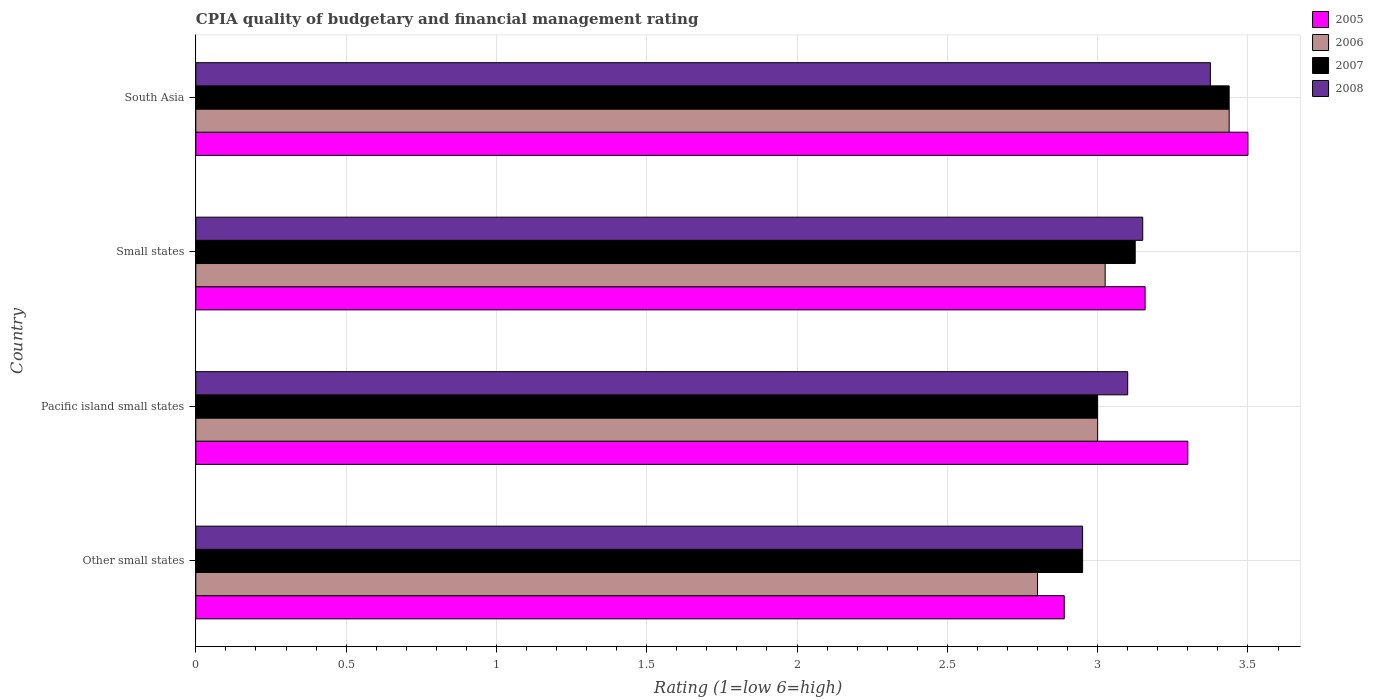Are the number of bars per tick equal to the number of legend labels?
Make the answer very short. Yes. How many bars are there on the 4th tick from the top?
Offer a terse response. 4. How many bars are there on the 2nd tick from the bottom?
Your response must be concise. 4. What is the label of the 1st group of bars from the top?
Offer a very short reply. South Asia. What is the CPIA rating in 2008 in Pacific island small states?
Offer a terse response. 3.1. Across all countries, what is the maximum CPIA rating in 2006?
Provide a short and direct response. 3.44. Across all countries, what is the minimum CPIA rating in 2007?
Your response must be concise. 2.95. In which country was the CPIA rating in 2006 minimum?
Provide a short and direct response. Other small states. What is the total CPIA rating in 2005 in the graph?
Give a very brief answer. 12.85. What is the difference between the CPIA rating in 2006 in Other small states and that in Small states?
Your response must be concise. -0.23. What is the difference between the CPIA rating in 2006 in Other small states and the CPIA rating in 2005 in Small states?
Provide a short and direct response. -0.36. What is the average CPIA rating in 2008 per country?
Offer a very short reply. 3.14. What is the difference between the CPIA rating in 2006 and CPIA rating in 2008 in Small states?
Make the answer very short. -0.12. In how many countries, is the CPIA rating in 2008 greater than 2.1 ?
Make the answer very short. 4. What is the ratio of the CPIA rating in 2007 in Other small states to that in Small states?
Ensure brevity in your answer.  0.94. Is the CPIA rating in 2006 in Other small states less than that in South Asia?
Your answer should be very brief. Yes. What is the difference between the highest and the second highest CPIA rating in 2006?
Give a very brief answer. 0.41. What is the difference between the highest and the lowest CPIA rating in 2008?
Make the answer very short. 0.42. In how many countries, is the CPIA rating in 2008 greater than the average CPIA rating in 2008 taken over all countries?
Keep it short and to the point. 2. What does the 1st bar from the top in Pacific island small states represents?
Provide a succinct answer. 2008. Are all the bars in the graph horizontal?
Provide a succinct answer. Yes. How many countries are there in the graph?
Ensure brevity in your answer.  4. Are the values on the major ticks of X-axis written in scientific E-notation?
Provide a succinct answer. No. Does the graph contain grids?
Offer a very short reply. Yes. Where does the legend appear in the graph?
Provide a succinct answer. Top right. How many legend labels are there?
Your answer should be very brief. 4. What is the title of the graph?
Your response must be concise. CPIA quality of budgetary and financial management rating. What is the label or title of the X-axis?
Offer a terse response. Rating (1=low 6=high). What is the Rating (1=low 6=high) in 2005 in Other small states?
Offer a terse response. 2.89. What is the Rating (1=low 6=high) in 2006 in Other small states?
Provide a succinct answer. 2.8. What is the Rating (1=low 6=high) in 2007 in Other small states?
Your response must be concise. 2.95. What is the Rating (1=low 6=high) in 2008 in Other small states?
Your answer should be compact. 2.95. What is the Rating (1=low 6=high) in 2005 in Pacific island small states?
Offer a terse response. 3.3. What is the Rating (1=low 6=high) in 2008 in Pacific island small states?
Make the answer very short. 3.1. What is the Rating (1=low 6=high) in 2005 in Small states?
Provide a short and direct response. 3.16. What is the Rating (1=low 6=high) of 2006 in Small states?
Keep it short and to the point. 3.02. What is the Rating (1=low 6=high) in 2007 in Small states?
Your answer should be very brief. 3.12. What is the Rating (1=low 6=high) of 2008 in Small states?
Make the answer very short. 3.15. What is the Rating (1=low 6=high) in 2005 in South Asia?
Keep it short and to the point. 3.5. What is the Rating (1=low 6=high) of 2006 in South Asia?
Provide a succinct answer. 3.44. What is the Rating (1=low 6=high) of 2007 in South Asia?
Provide a short and direct response. 3.44. What is the Rating (1=low 6=high) in 2008 in South Asia?
Offer a very short reply. 3.38. Across all countries, what is the maximum Rating (1=low 6=high) of 2006?
Make the answer very short. 3.44. Across all countries, what is the maximum Rating (1=low 6=high) of 2007?
Keep it short and to the point. 3.44. Across all countries, what is the maximum Rating (1=low 6=high) of 2008?
Offer a terse response. 3.38. Across all countries, what is the minimum Rating (1=low 6=high) in 2005?
Offer a terse response. 2.89. Across all countries, what is the minimum Rating (1=low 6=high) in 2007?
Your answer should be very brief. 2.95. Across all countries, what is the minimum Rating (1=low 6=high) of 2008?
Provide a short and direct response. 2.95. What is the total Rating (1=low 6=high) in 2005 in the graph?
Provide a succinct answer. 12.85. What is the total Rating (1=low 6=high) in 2006 in the graph?
Offer a terse response. 12.26. What is the total Rating (1=low 6=high) in 2007 in the graph?
Your answer should be very brief. 12.51. What is the total Rating (1=low 6=high) in 2008 in the graph?
Offer a very short reply. 12.57. What is the difference between the Rating (1=low 6=high) of 2005 in Other small states and that in Pacific island small states?
Ensure brevity in your answer.  -0.41. What is the difference between the Rating (1=low 6=high) of 2005 in Other small states and that in Small states?
Your response must be concise. -0.27. What is the difference between the Rating (1=low 6=high) in 2006 in Other small states and that in Small states?
Offer a very short reply. -0.23. What is the difference between the Rating (1=low 6=high) of 2007 in Other small states and that in Small states?
Provide a succinct answer. -0.17. What is the difference between the Rating (1=low 6=high) in 2005 in Other small states and that in South Asia?
Provide a short and direct response. -0.61. What is the difference between the Rating (1=low 6=high) in 2006 in Other small states and that in South Asia?
Make the answer very short. -0.64. What is the difference between the Rating (1=low 6=high) of 2007 in Other small states and that in South Asia?
Offer a very short reply. -0.49. What is the difference between the Rating (1=low 6=high) of 2008 in Other small states and that in South Asia?
Your response must be concise. -0.42. What is the difference between the Rating (1=low 6=high) in 2005 in Pacific island small states and that in Small states?
Make the answer very short. 0.14. What is the difference between the Rating (1=low 6=high) in 2006 in Pacific island small states and that in Small states?
Provide a succinct answer. -0.03. What is the difference between the Rating (1=low 6=high) of 2007 in Pacific island small states and that in Small states?
Keep it short and to the point. -0.12. What is the difference between the Rating (1=low 6=high) in 2008 in Pacific island small states and that in Small states?
Offer a terse response. -0.05. What is the difference between the Rating (1=low 6=high) in 2006 in Pacific island small states and that in South Asia?
Offer a terse response. -0.44. What is the difference between the Rating (1=low 6=high) in 2007 in Pacific island small states and that in South Asia?
Make the answer very short. -0.44. What is the difference between the Rating (1=low 6=high) in 2008 in Pacific island small states and that in South Asia?
Offer a very short reply. -0.28. What is the difference between the Rating (1=low 6=high) of 2005 in Small states and that in South Asia?
Ensure brevity in your answer.  -0.34. What is the difference between the Rating (1=low 6=high) of 2006 in Small states and that in South Asia?
Provide a succinct answer. -0.41. What is the difference between the Rating (1=low 6=high) in 2007 in Small states and that in South Asia?
Offer a very short reply. -0.31. What is the difference between the Rating (1=low 6=high) in 2008 in Small states and that in South Asia?
Your response must be concise. -0.23. What is the difference between the Rating (1=low 6=high) in 2005 in Other small states and the Rating (1=low 6=high) in 2006 in Pacific island small states?
Your response must be concise. -0.11. What is the difference between the Rating (1=low 6=high) of 2005 in Other small states and the Rating (1=low 6=high) of 2007 in Pacific island small states?
Your answer should be very brief. -0.11. What is the difference between the Rating (1=low 6=high) in 2005 in Other small states and the Rating (1=low 6=high) in 2008 in Pacific island small states?
Make the answer very short. -0.21. What is the difference between the Rating (1=low 6=high) of 2006 in Other small states and the Rating (1=low 6=high) of 2007 in Pacific island small states?
Offer a terse response. -0.2. What is the difference between the Rating (1=low 6=high) of 2007 in Other small states and the Rating (1=low 6=high) of 2008 in Pacific island small states?
Keep it short and to the point. -0.15. What is the difference between the Rating (1=low 6=high) in 2005 in Other small states and the Rating (1=low 6=high) in 2006 in Small states?
Provide a short and direct response. -0.14. What is the difference between the Rating (1=low 6=high) in 2005 in Other small states and the Rating (1=low 6=high) in 2007 in Small states?
Ensure brevity in your answer.  -0.24. What is the difference between the Rating (1=low 6=high) in 2005 in Other small states and the Rating (1=low 6=high) in 2008 in Small states?
Keep it short and to the point. -0.26. What is the difference between the Rating (1=low 6=high) of 2006 in Other small states and the Rating (1=low 6=high) of 2007 in Small states?
Provide a short and direct response. -0.33. What is the difference between the Rating (1=low 6=high) of 2006 in Other small states and the Rating (1=low 6=high) of 2008 in Small states?
Your answer should be compact. -0.35. What is the difference between the Rating (1=low 6=high) in 2005 in Other small states and the Rating (1=low 6=high) in 2006 in South Asia?
Offer a terse response. -0.55. What is the difference between the Rating (1=low 6=high) in 2005 in Other small states and the Rating (1=low 6=high) in 2007 in South Asia?
Your answer should be very brief. -0.55. What is the difference between the Rating (1=low 6=high) in 2005 in Other small states and the Rating (1=low 6=high) in 2008 in South Asia?
Offer a very short reply. -0.49. What is the difference between the Rating (1=low 6=high) of 2006 in Other small states and the Rating (1=low 6=high) of 2007 in South Asia?
Provide a short and direct response. -0.64. What is the difference between the Rating (1=low 6=high) in 2006 in Other small states and the Rating (1=low 6=high) in 2008 in South Asia?
Offer a very short reply. -0.57. What is the difference between the Rating (1=low 6=high) of 2007 in Other small states and the Rating (1=low 6=high) of 2008 in South Asia?
Your answer should be very brief. -0.42. What is the difference between the Rating (1=low 6=high) of 2005 in Pacific island small states and the Rating (1=low 6=high) of 2006 in Small states?
Ensure brevity in your answer.  0.28. What is the difference between the Rating (1=low 6=high) of 2005 in Pacific island small states and the Rating (1=low 6=high) of 2007 in Small states?
Your answer should be very brief. 0.17. What is the difference between the Rating (1=low 6=high) in 2006 in Pacific island small states and the Rating (1=low 6=high) in 2007 in Small states?
Provide a succinct answer. -0.12. What is the difference between the Rating (1=low 6=high) of 2007 in Pacific island small states and the Rating (1=low 6=high) of 2008 in Small states?
Your response must be concise. -0.15. What is the difference between the Rating (1=low 6=high) of 2005 in Pacific island small states and the Rating (1=low 6=high) of 2006 in South Asia?
Your answer should be very brief. -0.14. What is the difference between the Rating (1=low 6=high) of 2005 in Pacific island small states and the Rating (1=low 6=high) of 2007 in South Asia?
Give a very brief answer. -0.14. What is the difference between the Rating (1=low 6=high) in 2005 in Pacific island small states and the Rating (1=low 6=high) in 2008 in South Asia?
Provide a succinct answer. -0.07. What is the difference between the Rating (1=low 6=high) in 2006 in Pacific island small states and the Rating (1=low 6=high) in 2007 in South Asia?
Offer a terse response. -0.44. What is the difference between the Rating (1=low 6=high) of 2006 in Pacific island small states and the Rating (1=low 6=high) of 2008 in South Asia?
Your answer should be very brief. -0.38. What is the difference between the Rating (1=low 6=high) in 2007 in Pacific island small states and the Rating (1=low 6=high) in 2008 in South Asia?
Offer a very short reply. -0.38. What is the difference between the Rating (1=low 6=high) in 2005 in Small states and the Rating (1=low 6=high) in 2006 in South Asia?
Your answer should be compact. -0.28. What is the difference between the Rating (1=low 6=high) in 2005 in Small states and the Rating (1=low 6=high) in 2007 in South Asia?
Your answer should be compact. -0.28. What is the difference between the Rating (1=low 6=high) in 2005 in Small states and the Rating (1=low 6=high) in 2008 in South Asia?
Offer a very short reply. -0.22. What is the difference between the Rating (1=low 6=high) in 2006 in Small states and the Rating (1=low 6=high) in 2007 in South Asia?
Provide a short and direct response. -0.41. What is the difference between the Rating (1=low 6=high) in 2006 in Small states and the Rating (1=low 6=high) in 2008 in South Asia?
Your answer should be very brief. -0.35. What is the average Rating (1=low 6=high) of 2005 per country?
Offer a terse response. 3.21. What is the average Rating (1=low 6=high) in 2006 per country?
Give a very brief answer. 3.07. What is the average Rating (1=low 6=high) in 2007 per country?
Provide a succinct answer. 3.13. What is the average Rating (1=low 6=high) in 2008 per country?
Give a very brief answer. 3.14. What is the difference between the Rating (1=low 6=high) of 2005 and Rating (1=low 6=high) of 2006 in Other small states?
Offer a terse response. 0.09. What is the difference between the Rating (1=low 6=high) of 2005 and Rating (1=low 6=high) of 2007 in Other small states?
Your response must be concise. -0.06. What is the difference between the Rating (1=low 6=high) of 2005 and Rating (1=low 6=high) of 2008 in Other small states?
Provide a short and direct response. -0.06. What is the difference between the Rating (1=low 6=high) of 2006 and Rating (1=low 6=high) of 2007 in Other small states?
Keep it short and to the point. -0.15. What is the difference between the Rating (1=low 6=high) of 2007 and Rating (1=low 6=high) of 2008 in Other small states?
Make the answer very short. 0. What is the difference between the Rating (1=low 6=high) of 2005 and Rating (1=low 6=high) of 2007 in Pacific island small states?
Provide a succinct answer. 0.3. What is the difference between the Rating (1=low 6=high) of 2007 and Rating (1=low 6=high) of 2008 in Pacific island small states?
Offer a very short reply. -0.1. What is the difference between the Rating (1=low 6=high) of 2005 and Rating (1=low 6=high) of 2006 in Small states?
Keep it short and to the point. 0.13. What is the difference between the Rating (1=low 6=high) of 2005 and Rating (1=low 6=high) of 2007 in Small states?
Keep it short and to the point. 0.03. What is the difference between the Rating (1=low 6=high) in 2005 and Rating (1=low 6=high) in 2008 in Small states?
Your answer should be compact. 0.01. What is the difference between the Rating (1=low 6=high) in 2006 and Rating (1=low 6=high) in 2008 in Small states?
Offer a terse response. -0.12. What is the difference between the Rating (1=low 6=high) of 2007 and Rating (1=low 6=high) of 2008 in Small states?
Make the answer very short. -0.03. What is the difference between the Rating (1=low 6=high) of 2005 and Rating (1=low 6=high) of 2006 in South Asia?
Offer a very short reply. 0.06. What is the difference between the Rating (1=low 6=high) of 2005 and Rating (1=low 6=high) of 2007 in South Asia?
Offer a very short reply. 0.06. What is the difference between the Rating (1=low 6=high) of 2005 and Rating (1=low 6=high) of 2008 in South Asia?
Offer a terse response. 0.12. What is the difference between the Rating (1=low 6=high) in 2006 and Rating (1=low 6=high) in 2007 in South Asia?
Provide a short and direct response. 0. What is the difference between the Rating (1=low 6=high) of 2006 and Rating (1=low 6=high) of 2008 in South Asia?
Your answer should be very brief. 0.06. What is the difference between the Rating (1=low 6=high) in 2007 and Rating (1=low 6=high) in 2008 in South Asia?
Provide a short and direct response. 0.06. What is the ratio of the Rating (1=low 6=high) of 2005 in Other small states to that in Pacific island small states?
Your answer should be very brief. 0.88. What is the ratio of the Rating (1=low 6=high) of 2006 in Other small states to that in Pacific island small states?
Offer a terse response. 0.93. What is the ratio of the Rating (1=low 6=high) in 2007 in Other small states to that in Pacific island small states?
Ensure brevity in your answer.  0.98. What is the ratio of the Rating (1=low 6=high) in 2008 in Other small states to that in Pacific island small states?
Your response must be concise. 0.95. What is the ratio of the Rating (1=low 6=high) of 2005 in Other small states to that in Small states?
Your answer should be compact. 0.91. What is the ratio of the Rating (1=low 6=high) in 2006 in Other small states to that in Small states?
Provide a short and direct response. 0.93. What is the ratio of the Rating (1=low 6=high) in 2007 in Other small states to that in Small states?
Keep it short and to the point. 0.94. What is the ratio of the Rating (1=low 6=high) of 2008 in Other small states to that in Small states?
Keep it short and to the point. 0.94. What is the ratio of the Rating (1=low 6=high) in 2005 in Other small states to that in South Asia?
Ensure brevity in your answer.  0.83. What is the ratio of the Rating (1=low 6=high) in 2006 in Other small states to that in South Asia?
Make the answer very short. 0.81. What is the ratio of the Rating (1=low 6=high) of 2007 in Other small states to that in South Asia?
Provide a succinct answer. 0.86. What is the ratio of the Rating (1=low 6=high) in 2008 in Other small states to that in South Asia?
Ensure brevity in your answer.  0.87. What is the ratio of the Rating (1=low 6=high) in 2005 in Pacific island small states to that in Small states?
Your response must be concise. 1.04. What is the ratio of the Rating (1=low 6=high) in 2006 in Pacific island small states to that in Small states?
Ensure brevity in your answer.  0.99. What is the ratio of the Rating (1=low 6=high) in 2007 in Pacific island small states to that in Small states?
Ensure brevity in your answer.  0.96. What is the ratio of the Rating (1=low 6=high) in 2008 in Pacific island small states to that in Small states?
Give a very brief answer. 0.98. What is the ratio of the Rating (1=low 6=high) of 2005 in Pacific island small states to that in South Asia?
Give a very brief answer. 0.94. What is the ratio of the Rating (1=low 6=high) in 2006 in Pacific island small states to that in South Asia?
Offer a very short reply. 0.87. What is the ratio of the Rating (1=low 6=high) of 2007 in Pacific island small states to that in South Asia?
Offer a terse response. 0.87. What is the ratio of the Rating (1=low 6=high) of 2008 in Pacific island small states to that in South Asia?
Your response must be concise. 0.92. What is the ratio of the Rating (1=low 6=high) in 2005 in Small states to that in South Asia?
Offer a very short reply. 0.9. What is the ratio of the Rating (1=low 6=high) of 2006 in Small states to that in South Asia?
Keep it short and to the point. 0.88. What is the ratio of the Rating (1=low 6=high) of 2008 in Small states to that in South Asia?
Keep it short and to the point. 0.93. What is the difference between the highest and the second highest Rating (1=low 6=high) of 2006?
Provide a short and direct response. 0.41. What is the difference between the highest and the second highest Rating (1=low 6=high) in 2007?
Provide a short and direct response. 0.31. What is the difference between the highest and the second highest Rating (1=low 6=high) of 2008?
Keep it short and to the point. 0.23. What is the difference between the highest and the lowest Rating (1=low 6=high) of 2005?
Keep it short and to the point. 0.61. What is the difference between the highest and the lowest Rating (1=low 6=high) in 2006?
Provide a short and direct response. 0.64. What is the difference between the highest and the lowest Rating (1=low 6=high) in 2007?
Keep it short and to the point. 0.49. What is the difference between the highest and the lowest Rating (1=low 6=high) in 2008?
Provide a succinct answer. 0.42. 